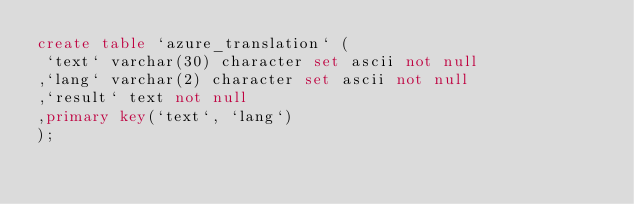Convert code to text. <code><loc_0><loc_0><loc_500><loc_500><_SQL_>create table `azure_translation` (
 `text` varchar(30) character set ascii not null
,`lang` varchar(2) character set ascii not null
,`result` text not null
,primary key(`text`, `lang`)
);
</code> 